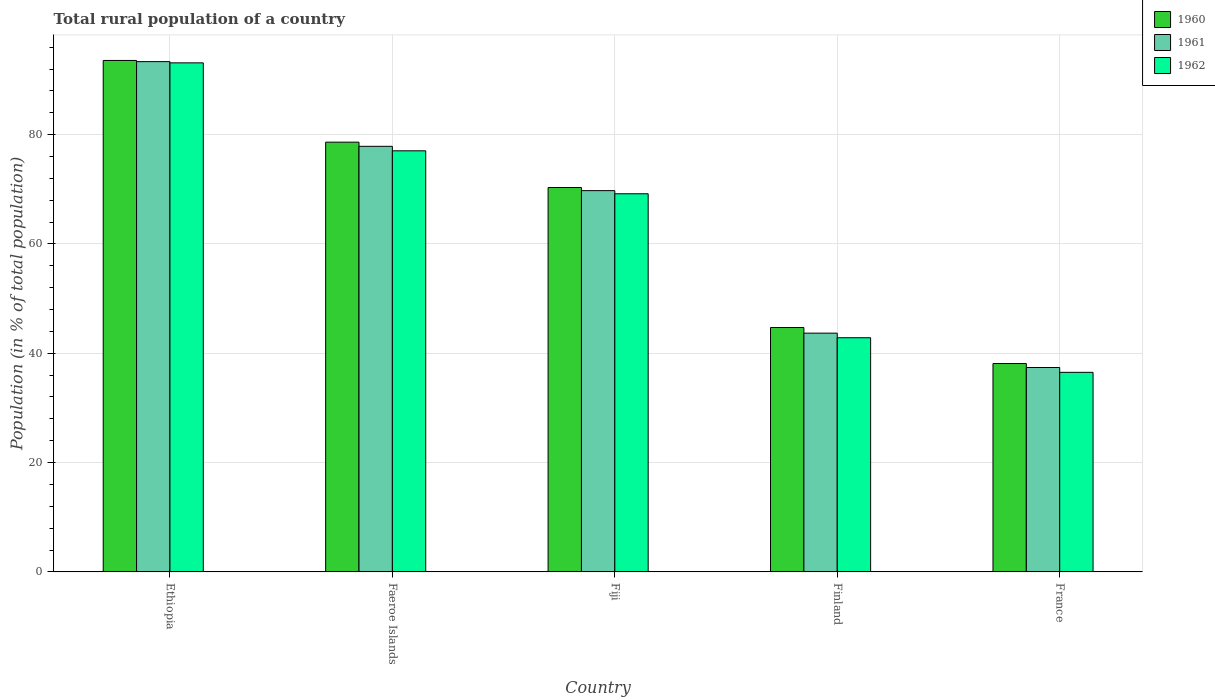How many groups of bars are there?
Keep it short and to the point. 5. How many bars are there on the 4th tick from the left?
Ensure brevity in your answer.  3. What is the label of the 3rd group of bars from the left?
Offer a very short reply. Fiji. In how many cases, is the number of bars for a given country not equal to the number of legend labels?
Provide a short and direct response. 0. What is the rural population in 1962 in Finland?
Make the answer very short. 42.84. Across all countries, what is the maximum rural population in 1961?
Your answer should be compact. 93.35. Across all countries, what is the minimum rural population in 1961?
Your answer should be very brief. 37.39. In which country was the rural population in 1960 maximum?
Your answer should be very brief. Ethiopia. What is the total rural population in 1962 in the graph?
Provide a succinct answer. 318.69. What is the difference between the rural population in 1962 in Ethiopia and that in France?
Offer a terse response. 56.62. What is the difference between the rural population in 1960 in Finland and the rural population in 1961 in Ethiopia?
Ensure brevity in your answer.  -48.64. What is the average rural population in 1962 per country?
Keep it short and to the point. 63.74. What is the difference between the rural population of/in 1961 and rural population of/in 1962 in Fiji?
Keep it short and to the point. 0.58. In how many countries, is the rural population in 1962 greater than 32 %?
Ensure brevity in your answer.  5. What is the ratio of the rural population in 1961 in Faeroe Islands to that in France?
Provide a short and direct response. 2.08. What is the difference between the highest and the second highest rural population in 1962?
Ensure brevity in your answer.  -7.86. What is the difference between the highest and the lowest rural population in 1962?
Keep it short and to the point. 56.62. In how many countries, is the rural population in 1961 greater than the average rural population in 1961 taken over all countries?
Offer a terse response. 3. Is the sum of the rural population in 1962 in Fiji and Finland greater than the maximum rural population in 1960 across all countries?
Provide a succinct answer. Yes. What does the 2nd bar from the left in France represents?
Your answer should be very brief. 1961. How many bars are there?
Ensure brevity in your answer.  15. Are all the bars in the graph horizontal?
Ensure brevity in your answer.  No. What is the difference between two consecutive major ticks on the Y-axis?
Make the answer very short. 20. Does the graph contain any zero values?
Offer a very short reply. No. Does the graph contain grids?
Keep it short and to the point. Yes. What is the title of the graph?
Ensure brevity in your answer.  Total rural population of a country. What is the label or title of the Y-axis?
Keep it short and to the point. Population (in % of total population). What is the Population (in % of total population) of 1960 in Ethiopia?
Your answer should be compact. 93.57. What is the Population (in % of total population) in 1961 in Ethiopia?
Keep it short and to the point. 93.35. What is the Population (in % of total population) in 1962 in Ethiopia?
Ensure brevity in your answer.  93.13. What is the Population (in % of total population) in 1960 in Faeroe Islands?
Offer a very short reply. 78.62. What is the Population (in % of total population) in 1961 in Faeroe Islands?
Give a very brief answer. 77.86. What is the Population (in % of total population) of 1962 in Faeroe Islands?
Provide a short and direct response. 77.04. What is the Population (in % of total population) in 1960 in Fiji?
Make the answer very short. 70.32. What is the Population (in % of total population) of 1961 in Fiji?
Keep it short and to the point. 69.75. What is the Population (in % of total population) of 1962 in Fiji?
Give a very brief answer. 69.18. What is the Population (in % of total population) in 1960 in Finland?
Offer a terse response. 44.71. What is the Population (in % of total population) in 1961 in Finland?
Ensure brevity in your answer.  43.68. What is the Population (in % of total population) in 1962 in Finland?
Ensure brevity in your answer.  42.84. What is the Population (in % of total population) of 1960 in France?
Keep it short and to the point. 38.12. What is the Population (in % of total population) in 1961 in France?
Offer a very short reply. 37.39. What is the Population (in % of total population) of 1962 in France?
Your answer should be very brief. 36.51. Across all countries, what is the maximum Population (in % of total population) of 1960?
Your response must be concise. 93.57. Across all countries, what is the maximum Population (in % of total population) of 1961?
Keep it short and to the point. 93.35. Across all countries, what is the maximum Population (in % of total population) of 1962?
Keep it short and to the point. 93.13. Across all countries, what is the minimum Population (in % of total population) of 1960?
Provide a succinct answer. 38.12. Across all countries, what is the minimum Population (in % of total population) of 1961?
Your answer should be compact. 37.39. Across all countries, what is the minimum Population (in % of total population) of 1962?
Keep it short and to the point. 36.51. What is the total Population (in % of total population) in 1960 in the graph?
Your answer should be compact. 325.33. What is the total Population (in % of total population) in 1961 in the graph?
Provide a succinct answer. 322.03. What is the total Population (in % of total population) of 1962 in the graph?
Your answer should be compact. 318.69. What is the difference between the Population (in % of total population) of 1960 in Ethiopia and that in Faeroe Islands?
Give a very brief answer. 14.95. What is the difference between the Population (in % of total population) in 1961 in Ethiopia and that in Faeroe Islands?
Give a very brief answer. 15.49. What is the difference between the Population (in % of total population) in 1962 in Ethiopia and that in Faeroe Islands?
Offer a terse response. 16.09. What is the difference between the Population (in % of total population) of 1960 in Ethiopia and that in Fiji?
Your answer should be very brief. 23.25. What is the difference between the Population (in % of total population) in 1961 in Ethiopia and that in Fiji?
Make the answer very short. 23.6. What is the difference between the Population (in % of total population) in 1962 in Ethiopia and that in Fiji?
Offer a very short reply. 23.95. What is the difference between the Population (in % of total population) of 1960 in Ethiopia and that in Finland?
Give a very brief answer. 48.86. What is the difference between the Population (in % of total population) in 1961 in Ethiopia and that in Finland?
Give a very brief answer. 49.67. What is the difference between the Population (in % of total population) of 1962 in Ethiopia and that in Finland?
Provide a short and direct response. 50.29. What is the difference between the Population (in % of total population) in 1960 in Ethiopia and that in France?
Make the answer very short. 55.45. What is the difference between the Population (in % of total population) of 1961 in Ethiopia and that in France?
Ensure brevity in your answer.  55.96. What is the difference between the Population (in % of total population) of 1962 in Ethiopia and that in France?
Your answer should be very brief. 56.62. What is the difference between the Population (in % of total population) of 1960 in Faeroe Islands and that in Fiji?
Keep it short and to the point. 8.3. What is the difference between the Population (in % of total population) in 1961 in Faeroe Islands and that in Fiji?
Provide a short and direct response. 8.11. What is the difference between the Population (in % of total population) in 1962 in Faeroe Islands and that in Fiji?
Make the answer very short. 7.86. What is the difference between the Population (in % of total population) in 1960 in Faeroe Islands and that in Finland?
Your answer should be very brief. 33.91. What is the difference between the Population (in % of total population) in 1961 in Faeroe Islands and that in Finland?
Give a very brief answer. 34.18. What is the difference between the Population (in % of total population) of 1962 in Faeroe Islands and that in Finland?
Keep it short and to the point. 34.2. What is the difference between the Population (in % of total population) in 1960 in Faeroe Islands and that in France?
Offer a very short reply. 40.5. What is the difference between the Population (in % of total population) of 1961 in Faeroe Islands and that in France?
Your response must be concise. 40.47. What is the difference between the Population (in % of total population) of 1962 in Faeroe Islands and that in France?
Ensure brevity in your answer.  40.53. What is the difference between the Population (in % of total population) of 1960 in Fiji and that in Finland?
Your answer should be very brief. 25.61. What is the difference between the Population (in % of total population) in 1961 in Fiji and that in Finland?
Ensure brevity in your answer.  26.07. What is the difference between the Population (in % of total population) in 1962 in Fiji and that in Finland?
Your response must be concise. 26.34. What is the difference between the Population (in % of total population) of 1960 in Fiji and that in France?
Offer a terse response. 32.2. What is the difference between the Population (in % of total population) in 1961 in Fiji and that in France?
Make the answer very short. 32.36. What is the difference between the Population (in % of total population) of 1962 in Fiji and that in France?
Provide a succinct answer. 32.67. What is the difference between the Population (in % of total population) of 1960 in Finland and that in France?
Give a very brief answer. 6.59. What is the difference between the Population (in % of total population) of 1961 in Finland and that in France?
Offer a terse response. 6.29. What is the difference between the Population (in % of total population) of 1962 in Finland and that in France?
Ensure brevity in your answer.  6.33. What is the difference between the Population (in % of total population) of 1960 in Ethiopia and the Population (in % of total population) of 1961 in Faeroe Islands?
Give a very brief answer. 15.71. What is the difference between the Population (in % of total population) in 1960 in Ethiopia and the Population (in % of total population) in 1962 in Faeroe Islands?
Provide a succinct answer. 16.53. What is the difference between the Population (in % of total population) of 1961 in Ethiopia and the Population (in % of total population) of 1962 in Faeroe Islands?
Your answer should be very brief. 16.31. What is the difference between the Population (in % of total population) in 1960 in Ethiopia and the Population (in % of total population) in 1961 in Fiji?
Keep it short and to the point. 23.82. What is the difference between the Population (in % of total population) in 1960 in Ethiopia and the Population (in % of total population) in 1962 in Fiji?
Offer a terse response. 24.39. What is the difference between the Population (in % of total population) in 1961 in Ethiopia and the Population (in % of total population) in 1962 in Fiji?
Make the answer very short. 24.17. What is the difference between the Population (in % of total population) in 1960 in Ethiopia and the Population (in % of total population) in 1961 in Finland?
Your response must be concise. 49.89. What is the difference between the Population (in % of total population) in 1960 in Ethiopia and the Population (in % of total population) in 1962 in Finland?
Offer a terse response. 50.73. What is the difference between the Population (in % of total population) of 1961 in Ethiopia and the Population (in % of total population) of 1962 in Finland?
Provide a short and direct response. 50.51. What is the difference between the Population (in % of total population) of 1960 in Ethiopia and the Population (in % of total population) of 1961 in France?
Provide a short and direct response. 56.17. What is the difference between the Population (in % of total population) of 1960 in Ethiopia and the Population (in % of total population) of 1962 in France?
Keep it short and to the point. 57.06. What is the difference between the Population (in % of total population) of 1961 in Ethiopia and the Population (in % of total population) of 1962 in France?
Your answer should be very brief. 56.84. What is the difference between the Population (in % of total population) in 1960 in Faeroe Islands and the Population (in % of total population) in 1961 in Fiji?
Your response must be concise. 8.87. What is the difference between the Population (in % of total population) of 1960 in Faeroe Islands and the Population (in % of total population) of 1962 in Fiji?
Keep it short and to the point. 9.44. What is the difference between the Population (in % of total population) in 1961 in Faeroe Islands and the Population (in % of total population) in 1962 in Fiji?
Offer a very short reply. 8.68. What is the difference between the Population (in % of total population) in 1960 in Faeroe Islands and the Population (in % of total population) in 1961 in Finland?
Keep it short and to the point. 34.94. What is the difference between the Population (in % of total population) in 1960 in Faeroe Islands and the Population (in % of total population) in 1962 in Finland?
Your response must be concise. 35.78. What is the difference between the Population (in % of total population) in 1961 in Faeroe Islands and the Population (in % of total population) in 1962 in Finland?
Your answer should be compact. 35.02. What is the difference between the Population (in % of total population) of 1960 in Faeroe Islands and the Population (in % of total population) of 1961 in France?
Your answer should be compact. 41.22. What is the difference between the Population (in % of total population) in 1960 in Faeroe Islands and the Population (in % of total population) in 1962 in France?
Give a very brief answer. 42.11. What is the difference between the Population (in % of total population) in 1961 in Faeroe Islands and the Population (in % of total population) in 1962 in France?
Ensure brevity in your answer.  41.35. What is the difference between the Population (in % of total population) of 1960 in Fiji and the Population (in % of total population) of 1961 in Finland?
Offer a terse response. 26.64. What is the difference between the Population (in % of total population) in 1960 in Fiji and the Population (in % of total population) in 1962 in Finland?
Provide a short and direct response. 27.48. What is the difference between the Population (in % of total population) in 1961 in Fiji and the Population (in % of total population) in 1962 in Finland?
Give a very brief answer. 26.91. What is the difference between the Population (in % of total population) in 1960 in Fiji and the Population (in % of total population) in 1961 in France?
Give a very brief answer. 32.93. What is the difference between the Population (in % of total population) in 1960 in Fiji and the Population (in % of total population) in 1962 in France?
Give a very brief answer. 33.81. What is the difference between the Population (in % of total population) in 1961 in Fiji and the Population (in % of total population) in 1962 in France?
Provide a short and direct response. 33.24. What is the difference between the Population (in % of total population) in 1960 in Finland and the Population (in % of total population) in 1961 in France?
Offer a very short reply. 7.32. What is the difference between the Population (in % of total population) of 1960 in Finland and the Population (in % of total population) of 1962 in France?
Make the answer very short. 8.2. What is the difference between the Population (in % of total population) of 1961 in Finland and the Population (in % of total population) of 1962 in France?
Give a very brief answer. 7.17. What is the average Population (in % of total population) in 1960 per country?
Your response must be concise. 65.07. What is the average Population (in % of total population) of 1961 per country?
Offer a terse response. 64.41. What is the average Population (in % of total population) of 1962 per country?
Keep it short and to the point. 63.74. What is the difference between the Population (in % of total population) of 1960 and Population (in % of total population) of 1961 in Ethiopia?
Offer a very short reply. 0.22. What is the difference between the Population (in % of total population) in 1960 and Population (in % of total population) in 1962 in Ethiopia?
Offer a terse response. 0.44. What is the difference between the Population (in % of total population) of 1961 and Population (in % of total population) of 1962 in Ethiopia?
Your response must be concise. 0.22. What is the difference between the Population (in % of total population) in 1960 and Population (in % of total population) in 1961 in Faeroe Islands?
Ensure brevity in your answer.  0.76. What is the difference between the Population (in % of total population) in 1960 and Population (in % of total population) in 1962 in Faeroe Islands?
Offer a very short reply. 1.58. What is the difference between the Population (in % of total population) in 1961 and Population (in % of total population) in 1962 in Faeroe Islands?
Give a very brief answer. 0.82. What is the difference between the Population (in % of total population) of 1960 and Population (in % of total population) of 1961 in Fiji?
Offer a very short reply. 0.57. What is the difference between the Population (in % of total population) of 1960 and Population (in % of total population) of 1962 in Fiji?
Offer a very short reply. 1.14. What is the difference between the Population (in % of total population) of 1961 and Population (in % of total population) of 1962 in Fiji?
Your answer should be very brief. 0.57. What is the difference between the Population (in % of total population) of 1960 and Population (in % of total population) of 1961 in Finland?
Offer a very short reply. 1.03. What is the difference between the Population (in % of total population) of 1960 and Population (in % of total population) of 1962 in Finland?
Provide a short and direct response. 1.87. What is the difference between the Population (in % of total population) in 1961 and Population (in % of total population) in 1962 in Finland?
Give a very brief answer. 0.84. What is the difference between the Population (in % of total population) in 1960 and Population (in % of total population) in 1961 in France?
Your answer should be compact. 0.73. What is the difference between the Population (in % of total population) in 1960 and Population (in % of total population) in 1962 in France?
Offer a very short reply. 1.61. What is the difference between the Population (in % of total population) of 1961 and Population (in % of total population) of 1962 in France?
Your response must be concise. 0.88. What is the ratio of the Population (in % of total population) of 1960 in Ethiopia to that in Faeroe Islands?
Provide a short and direct response. 1.19. What is the ratio of the Population (in % of total population) in 1961 in Ethiopia to that in Faeroe Islands?
Provide a succinct answer. 1.2. What is the ratio of the Population (in % of total population) of 1962 in Ethiopia to that in Faeroe Islands?
Your answer should be compact. 1.21. What is the ratio of the Population (in % of total population) in 1960 in Ethiopia to that in Fiji?
Your response must be concise. 1.33. What is the ratio of the Population (in % of total population) in 1961 in Ethiopia to that in Fiji?
Provide a succinct answer. 1.34. What is the ratio of the Population (in % of total population) of 1962 in Ethiopia to that in Fiji?
Offer a very short reply. 1.35. What is the ratio of the Population (in % of total population) of 1960 in Ethiopia to that in Finland?
Provide a succinct answer. 2.09. What is the ratio of the Population (in % of total population) of 1961 in Ethiopia to that in Finland?
Your answer should be compact. 2.14. What is the ratio of the Population (in % of total population) of 1962 in Ethiopia to that in Finland?
Your answer should be compact. 2.17. What is the ratio of the Population (in % of total population) of 1960 in Ethiopia to that in France?
Make the answer very short. 2.45. What is the ratio of the Population (in % of total population) in 1961 in Ethiopia to that in France?
Your answer should be compact. 2.5. What is the ratio of the Population (in % of total population) of 1962 in Ethiopia to that in France?
Make the answer very short. 2.55. What is the ratio of the Population (in % of total population) in 1960 in Faeroe Islands to that in Fiji?
Give a very brief answer. 1.12. What is the ratio of the Population (in % of total population) of 1961 in Faeroe Islands to that in Fiji?
Give a very brief answer. 1.12. What is the ratio of the Population (in % of total population) in 1962 in Faeroe Islands to that in Fiji?
Provide a short and direct response. 1.11. What is the ratio of the Population (in % of total population) of 1960 in Faeroe Islands to that in Finland?
Make the answer very short. 1.76. What is the ratio of the Population (in % of total population) of 1961 in Faeroe Islands to that in Finland?
Your answer should be compact. 1.78. What is the ratio of the Population (in % of total population) of 1962 in Faeroe Islands to that in Finland?
Provide a succinct answer. 1.8. What is the ratio of the Population (in % of total population) in 1960 in Faeroe Islands to that in France?
Offer a terse response. 2.06. What is the ratio of the Population (in % of total population) in 1961 in Faeroe Islands to that in France?
Give a very brief answer. 2.08. What is the ratio of the Population (in % of total population) in 1962 in Faeroe Islands to that in France?
Provide a succinct answer. 2.11. What is the ratio of the Population (in % of total population) in 1960 in Fiji to that in Finland?
Your response must be concise. 1.57. What is the ratio of the Population (in % of total population) in 1961 in Fiji to that in Finland?
Offer a very short reply. 1.6. What is the ratio of the Population (in % of total population) of 1962 in Fiji to that in Finland?
Give a very brief answer. 1.61. What is the ratio of the Population (in % of total population) of 1960 in Fiji to that in France?
Provide a short and direct response. 1.84. What is the ratio of the Population (in % of total population) of 1961 in Fiji to that in France?
Offer a terse response. 1.87. What is the ratio of the Population (in % of total population) of 1962 in Fiji to that in France?
Your response must be concise. 1.89. What is the ratio of the Population (in % of total population) of 1960 in Finland to that in France?
Give a very brief answer. 1.17. What is the ratio of the Population (in % of total population) of 1961 in Finland to that in France?
Your response must be concise. 1.17. What is the ratio of the Population (in % of total population) in 1962 in Finland to that in France?
Your answer should be very brief. 1.17. What is the difference between the highest and the second highest Population (in % of total population) in 1960?
Offer a very short reply. 14.95. What is the difference between the highest and the second highest Population (in % of total population) of 1961?
Your answer should be compact. 15.49. What is the difference between the highest and the second highest Population (in % of total population) of 1962?
Your answer should be very brief. 16.09. What is the difference between the highest and the lowest Population (in % of total population) in 1960?
Your answer should be compact. 55.45. What is the difference between the highest and the lowest Population (in % of total population) in 1961?
Your answer should be very brief. 55.96. What is the difference between the highest and the lowest Population (in % of total population) of 1962?
Keep it short and to the point. 56.62. 